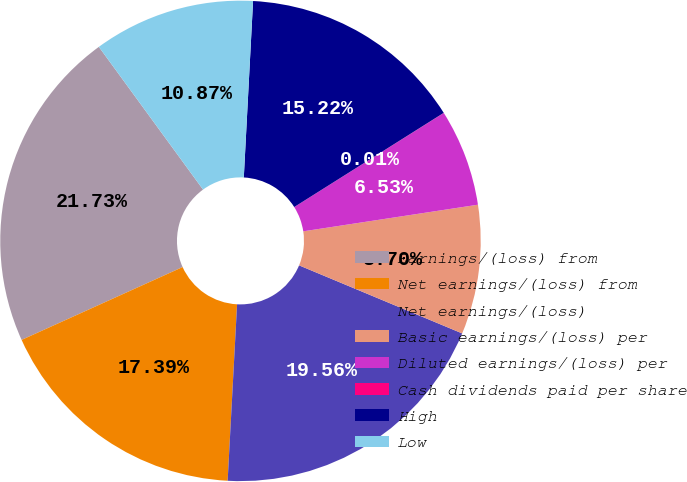<chart> <loc_0><loc_0><loc_500><loc_500><pie_chart><fcel>Earnings/(loss) from<fcel>Net earnings/(loss) from<fcel>Net earnings/(loss)<fcel>Basic earnings/(loss) per<fcel>Diluted earnings/(loss) per<fcel>Cash dividends paid per share<fcel>High<fcel>Low<nl><fcel>21.73%<fcel>17.39%<fcel>19.56%<fcel>8.7%<fcel>6.53%<fcel>0.01%<fcel>15.22%<fcel>10.87%<nl></chart> 